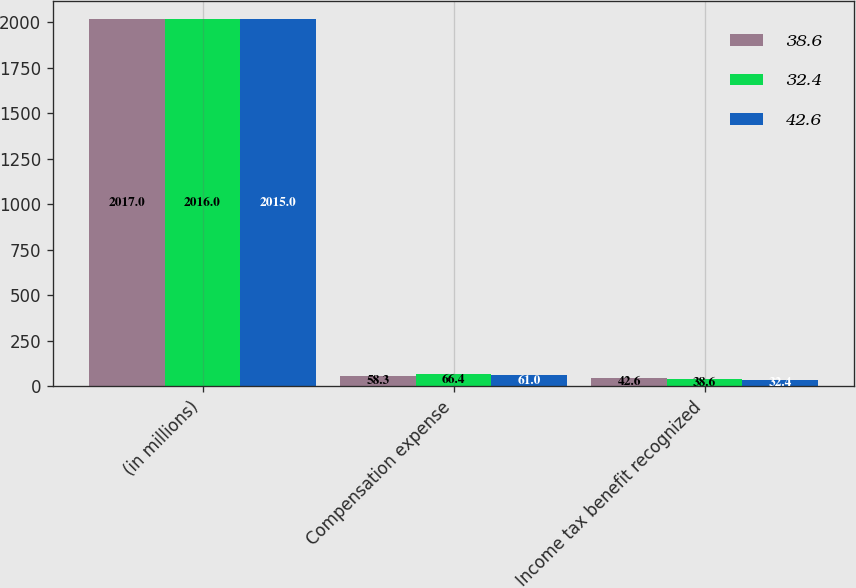Convert chart. <chart><loc_0><loc_0><loc_500><loc_500><stacked_bar_chart><ecel><fcel>(in millions)<fcel>Compensation expense<fcel>Income tax benefit recognized<nl><fcel>38.6<fcel>2017<fcel>58.3<fcel>42.6<nl><fcel>32.4<fcel>2016<fcel>66.4<fcel>38.6<nl><fcel>42.6<fcel>2015<fcel>61<fcel>32.4<nl></chart> 